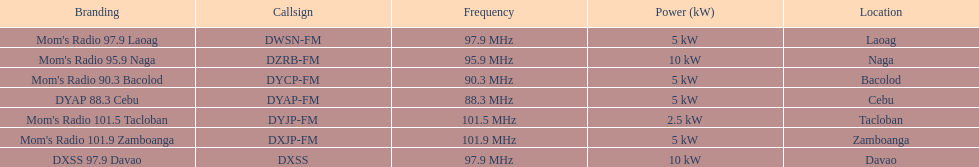How many instances is the frequency exceeding 95? 5. 